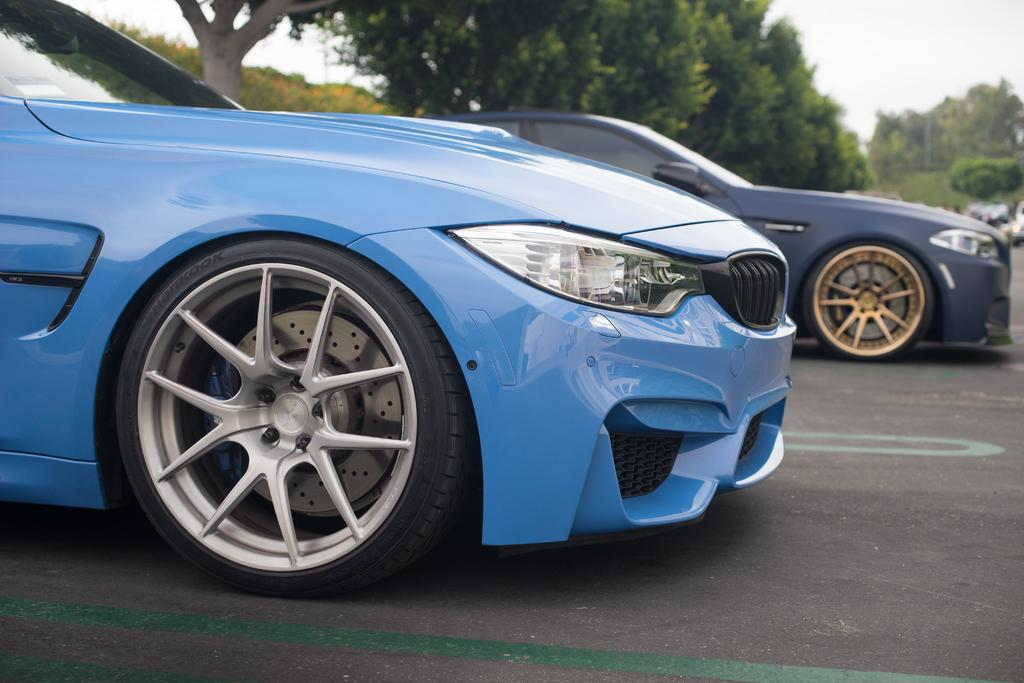What can be seen on the road in the image? There are cars on the road in the image. What type of vegetation is visible in the background of the image? There are trees in the background of the image. What else can be seen in the background of the image? The sky is visible in the background of the image. Can you describe the insect crawling on the car in the image? There is no insect visible on the cars in the image. 